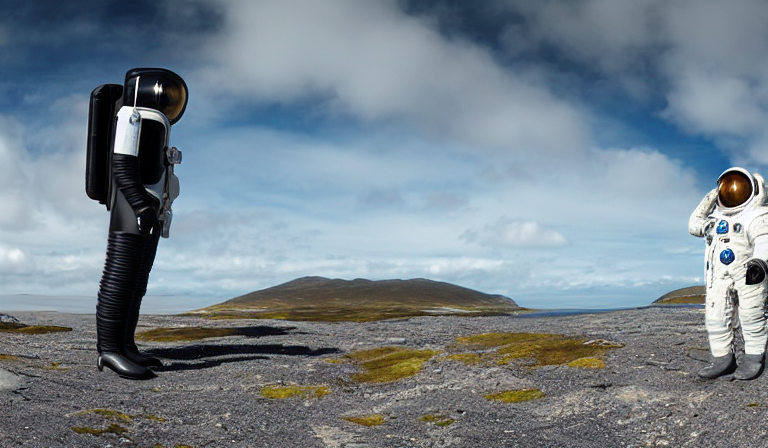What is the lighting condition in this image?
A. overexposed with a high contrast scene
B. dimly lit with a dark scene
C. well-lit with a bright scene
Answer with the option's letter from the given choices directly.
 C. 